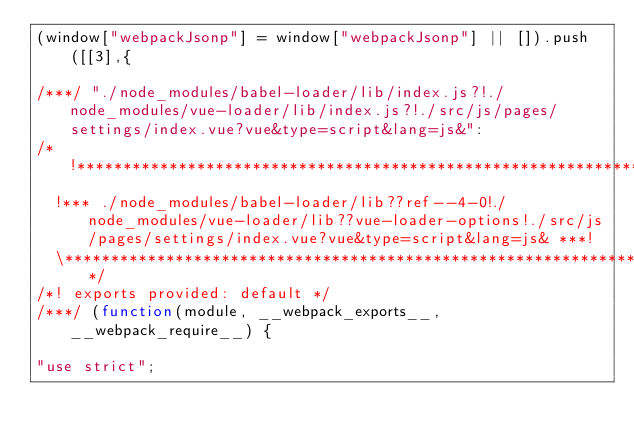<code> <loc_0><loc_0><loc_500><loc_500><_JavaScript_>(window["webpackJsonp"] = window["webpackJsonp"] || []).push([[3],{

/***/ "./node_modules/babel-loader/lib/index.js?!./node_modules/vue-loader/lib/index.js?!./src/js/pages/settings/index.vue?vue&type=script&lang=js&":
/*!**************************************************************************************************************************************************************!*\
  !*** ./node_modules/babel-loader/lib??ref--4-0!./node_modules/vue-loader/lib??vue-loader-options!./src/js/pages/settings/index.vue?vue&type=script&lang=js& ***!
  \**************************************************************************************************************************************************************/
/*! exports provided: default */
/***/ (function(module, __webpack_exports__, __webpack_require__) {

"use strict";</code> 